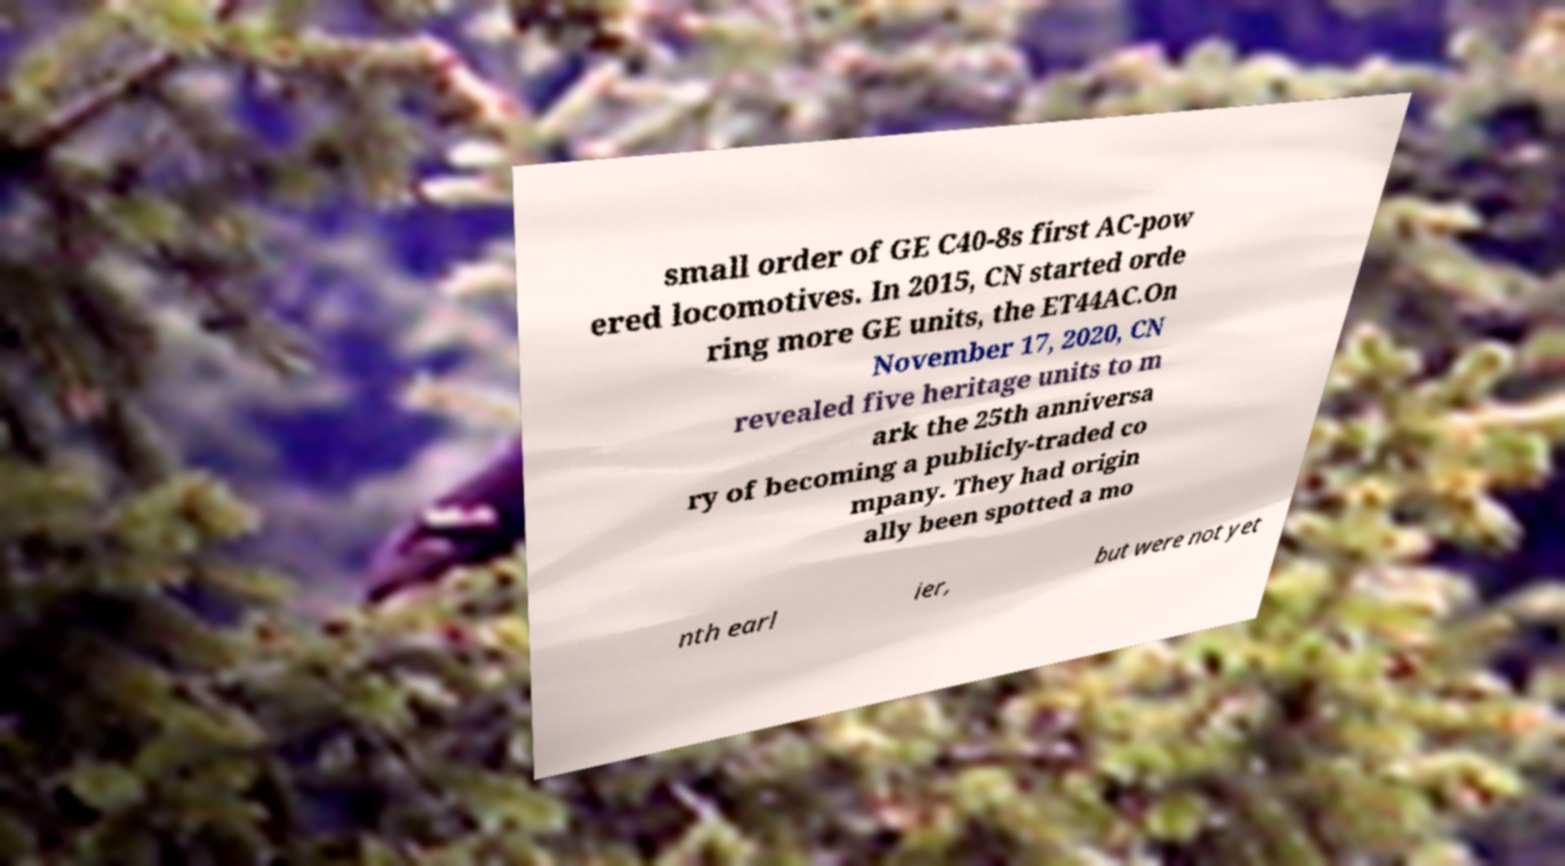Can you read and provide the text displayed in the image?This photo seems to have some interesting text. Can you extract and type it out for me? small order of GE C40-8s first AC-pow ered locomotives. In 2015, CN started orde ring more GE units, the ET44AC.On November 17, 2020, CN revealed five heritage units to m ark the 25th anniversa ry of becoming a publicly-traded co mpany. They had origin ally been spotted a mo nth earl ier, but were not yet 